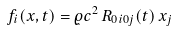<formula> <loc_0><loc_0><loc_500><loc_500>f _ { i } ( { x } , t ) = \varrho c ^ { 2 } \, R _ { 0 i 0 j } ( t ) \, x _ { j }</formula> 